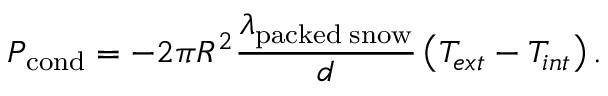<formula> <loc_0><loc_0><loc_500><loc_500>P _ { c o n d } = - 2 \pi R ^ { 2 } \frac { \lambda _ { p a c k e d \, s n o w } } { d } \left ( T _ { e x t } - T _ { i n t } \right ) .</formula> 